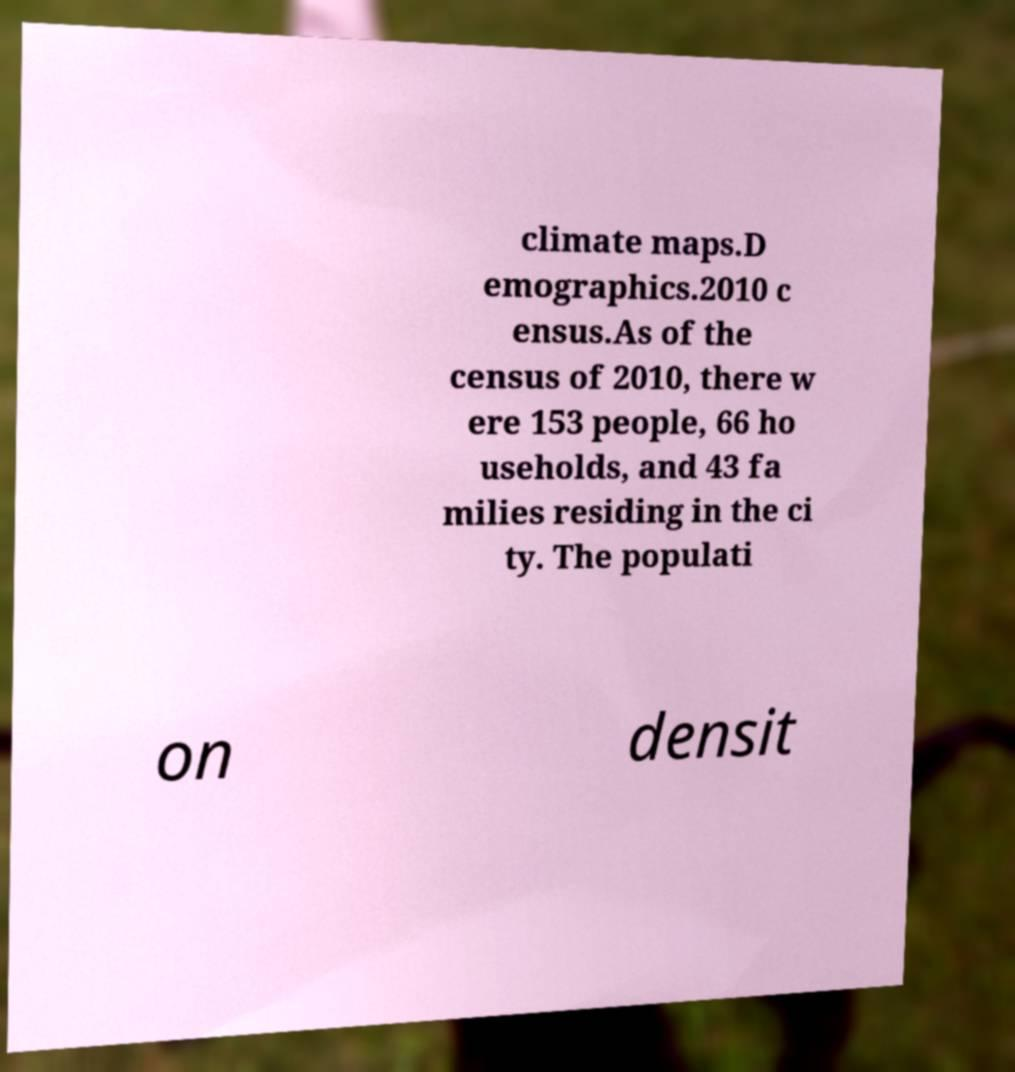There's text embedded in this image that I need extracted. Can you transcribe it verbatim? climate maps.D emographics.2010 c ensus.As of the census of 2010, there w ere 153 people, 66 ho useholds, and 43 fa milies residing in the ci ty. The populati on densit 